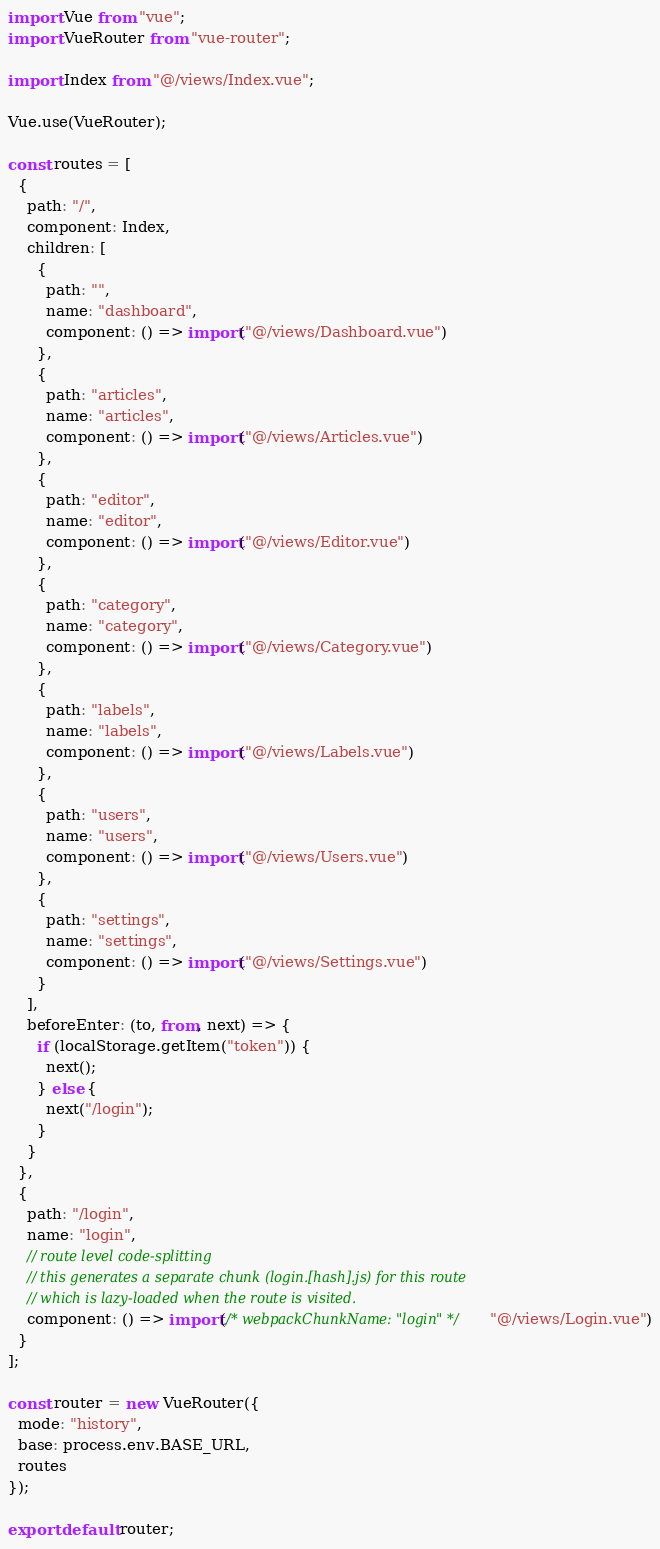Convert code to text. <code><loc_0><loc_0><loc_500><loc_500><_JavaScript_>import Vue from "vue";
import VueRouter from "vue-router";

import Index from "@/views/Index.vue";

Vue.use(VueRouter);

const routes = [
  {
    path: "/",
    component: Index,
    children: [
      {
        path: "",
        name: "dashboard",
        component: () => import("@/views/Dashboard.vue")
      },
      {
        path: "articles",
        name: "articles",
        component: () => import("@/views/Articles.vue")
      },
      {
        path: "editor",
        name: "editor",
        component: () => import("@/views/Editor.vue")
      },
      {
        path: "category",
        name: "category",
        component: () => import("@/views/Category.vue")
      },
      {
        path: "labels",
        name: "labels",
        component: () => import("@/views/Labels.vue")
      },
      {
        path: "users",
        name: "users",
        component: () => import("@/views/Users.vue")
      },
      {
        path: "settings",
        name: "settings",
        component: () => import("@/views/Settings.vue")
      }
    ],
    beforeEnter: (to, from, next) => {
      if (localStorage.getItem("token")) {
        next();
      } else {
        next("/login");
      }
    }
  },
  {
    path: "/login",
    name: "login",
    // route level code-splitting
    // this generates a separate chunk (login.[hash].js) for this route
    // which is lazy-loaded when the route is visited.
    component: () => import(/* webpackChunkName: "login" */ "@/views/Login.vue")
  }
];

const router = new VueRouter({
  mode: "history",
  base: process.env.BASE_URL,
  routes
});

export default router;
</code> 